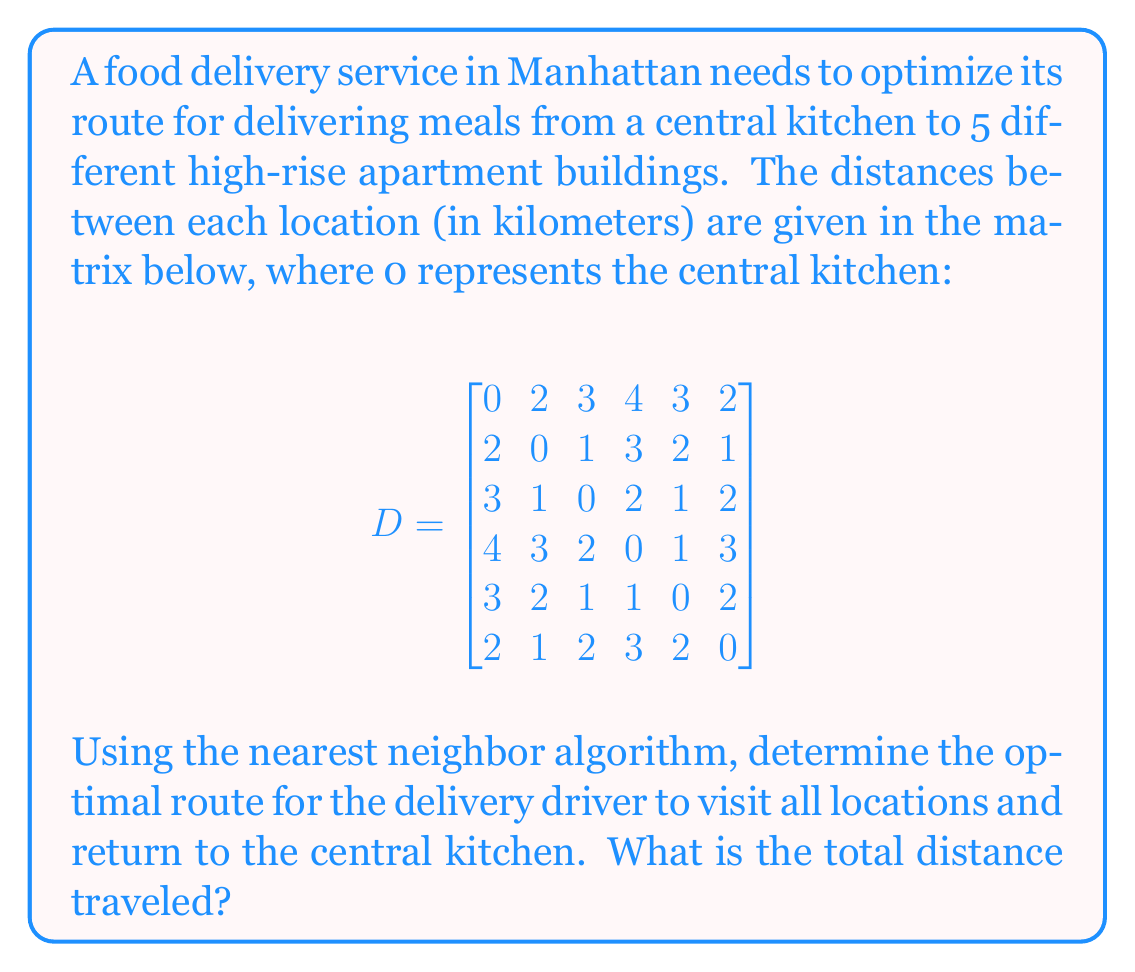Can you answer this question? To solve this problem using the nearest neighbor algorithm, we'll follow these steps:

1) Start at the central kitchen (location 0).
2) Find the nearest unvisited location.
3) Move to that location.
4) Repeat steps 2 and 3 until all locations have been visited.
5) Return to the central kitchen.

Let's go through this process:

1) Start at location 0 (central kitchen).

2) From location 0, the nearest location is either 1 or 5 (both 2 km away). Let's choose 1.
   Route so far: 0 -> 1
   Distance: 2 km

3) From location 1, the nearest unvisited location is 2 (1 km away).
   Route so far: 0 -> 1 -> 2
   Distance: 2 + 1 = 3 km

4) From location 2, the nearest unvisited location is 4 (1 km away).
   Route so far: 0 -> 1 -> 2 -> 4
   Distance: 3 + 1 = 4 km

5) From location 4, the nearest unvisited location is 3 (1 km away).
   Route so far: 0 -> 1 -> 2 -> 4 -> 3
   Distance: 4 + 1 = 5 km

6) Location 5 is the only location left unvisited. The distance from 3 to 5 is 3 km.
   Route so far: 0 -> 1 -> 2 -> 4 -> 3 -> 5
   Distance: 5 + 3 = 8 km

7) Finally, return to the central kitchen (location 0) from location 5. This distance is 2 km.
   Final route: 0 -> 1 -> 2 -> 4 -> 3 -> 5 -> 0
   Total distance: 8 + 2 = 10 km

Therefore, the optimal route according to the nearest neighbor algorithm is 0 -> 1 -> 2 -> 4 -> 3 -> 5 -> 0, with a total distance of 10 km.
Answer: The optimal route is 0 -> 1 -> 2 -> 4 -> 3 -> 5 -> 0, and the total distance traveled is 10 km. 